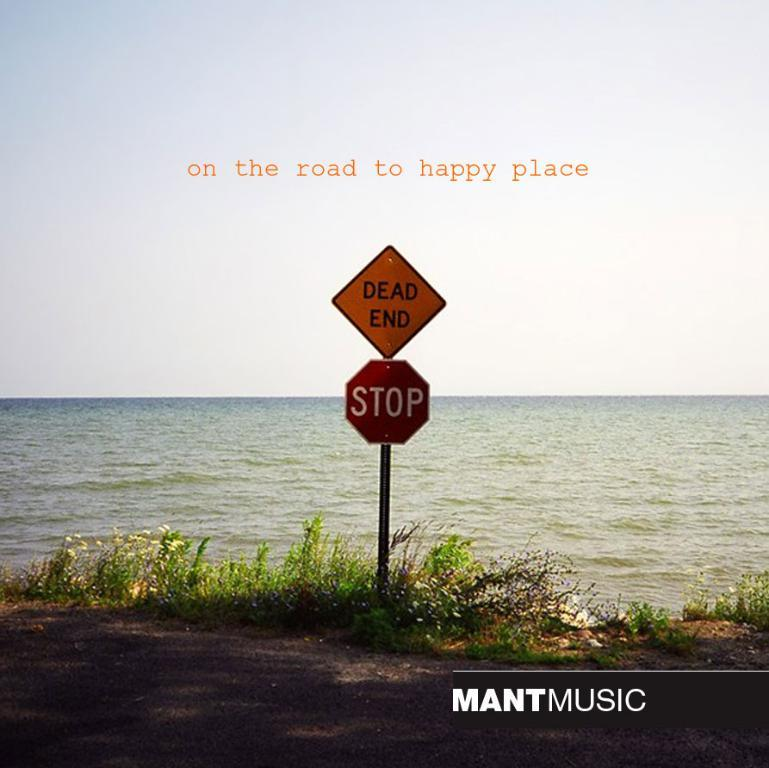<image>
Offer a succinct explanation of the picture presented. The picture makes a dead end road seem like a happy place on the road. 